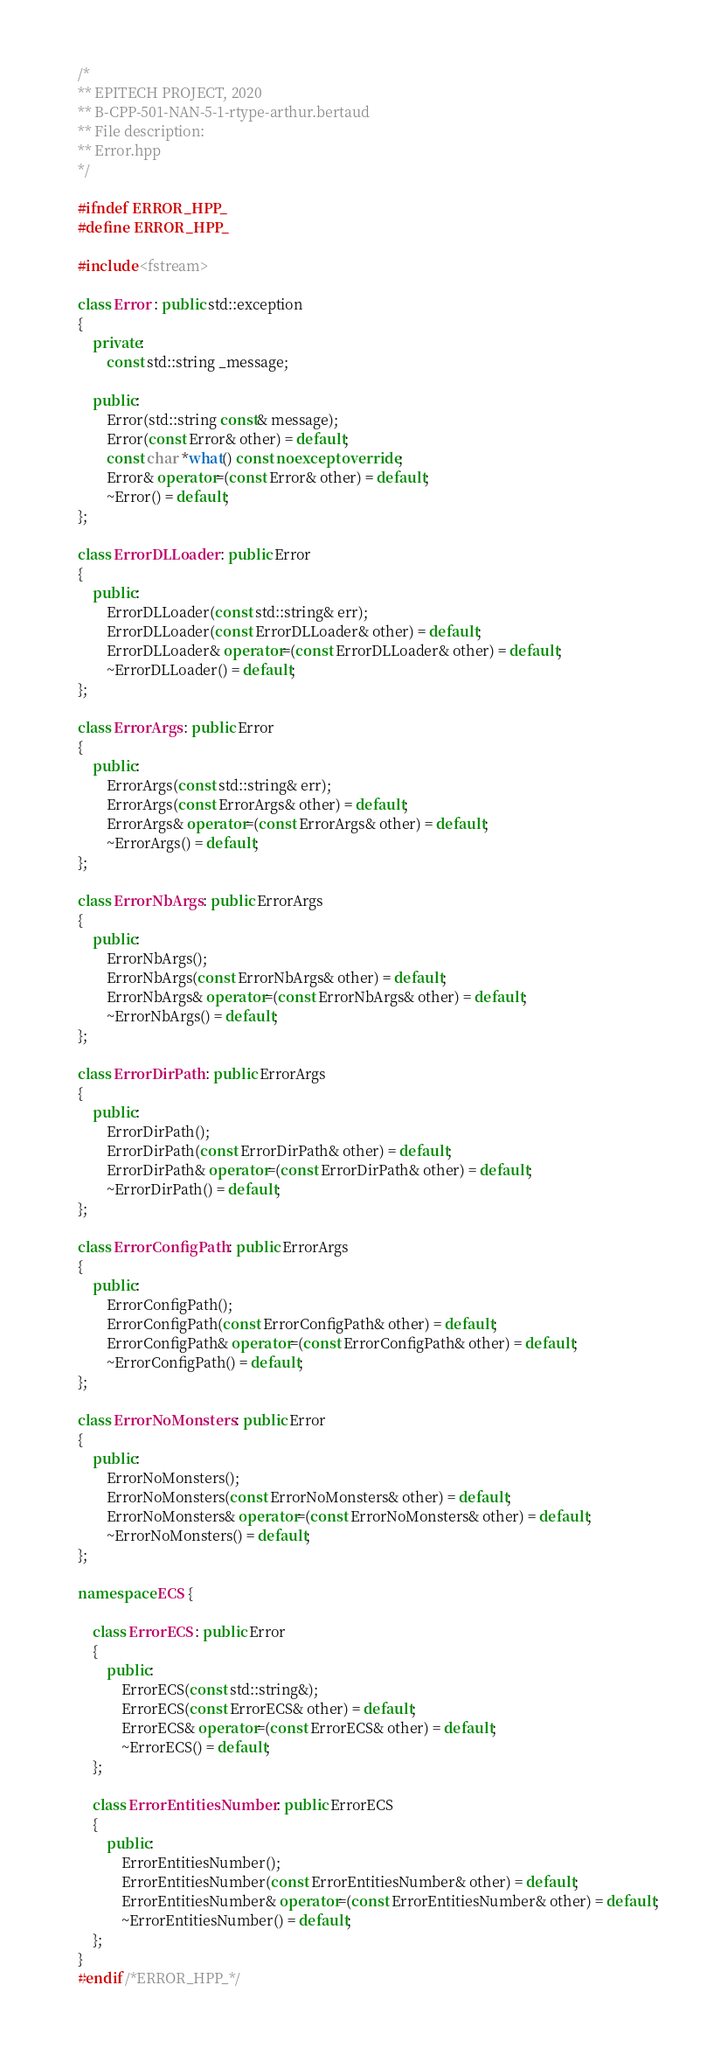<code> <loc_0><loc_0><loc_500><loc_500><_C++_>/*
** EPITECH PROJECT, 2020
** B-CPP-501-NAN-5-1-rtype-arthur.bertaud
** File description:
** Error.hpp
*/

#ifndef ERROR_HPP_
#define ERROR_HPP_

#include <fstream>

class Error : public std::exception
{
    private:
        const std::string _message;

    public:
        Error(std::string const& message);
        Error(const Error& other) = default;
        const char *what() const noexcept override;
        Error& operator=(const Error& other) = default;
        ~Error() = default;
};

class ErrorDLLoader : public Error
{
    public:
        ErrorDLLoader(const std::string& err);
        ErrorDLLoader(const ErrorDLLoader& other) = default;
        ErrorDLLoader& operator=(const ErrorDLLoader& other) = default;
        ~ErrorDLLoader() = default;
};

class ErrorArgs : public Error
{
    public:
        ErrorArgs(const std::string& err);
        ErrorArgs(const ErrorArgs& other) = default;
        ErrorArgs& operator=(const ErrorArgs& other) = default;
        ~ErrorArgs() = default;
};

class ErrorNbArgs : public ErrorArgs
{
    public:
        ErrorNbArgs();
        ErrorNbArgs(const ErrorNbArgs& other) = default;
        ErrorNbArgs& operator=(const ErrorNbArgs& other) = default;
        ~ErrorNbArgs() = default;
};

class ErrorDirPath : public ErrorArgs
{
    public:
        ErrorDirPath();
        ErrorDirPath(const ErrorDirPath& other) = default;
        ErrorDirPath& operator=(const ErrorDirPath& other) = default;
        ~ErrorDirPath() = default;
};

class ErrorConfigPath : public ErrorArgs
{
    public:
        ErrorConfigPath();
        ErrorConfigPath(const ErrorConfigPath& other) = default;
        ErrorConfigPath& operator=(const ErrorConfigPath& other) = default;
        ~ErrorConfigPath() = default;
};

class ErrorNoMonsters : public Error
{
    public:
        ErrorNoMonsters();
        ErrorNoMonsters(const ErrorNoMonsters& other) = default;
        ErrorNoMonsters& operator=(const ErrorNoMonsters& other) = default;
        ~ErrorNoMonsters() = default;
};

namespace ECS {

    class ErrorECS : public Error
    {
        public:
            ErrorECS(const std::string&);
            ErrorECS(const ErrorECS& other) = default;
            ErrorECS& operator=(const ErrorECS& other) = default;
            ~ErrorECS() = default;
    };

    class ErrorEntitiesNumber : public ErrorECS
    {
        public:
            ErrorEntitiesNumber();
            ErrorEntitiesNumber(const ErrorEntitiesNumber& other) = default;
            ErrorEntitiesNumber& operator=(const ErrorEntitiesNumber& other) = default;
            ~ErrorEntitiesNumber() = default;
    };
}
#endif /*ERROR_HPP_*/</code> 